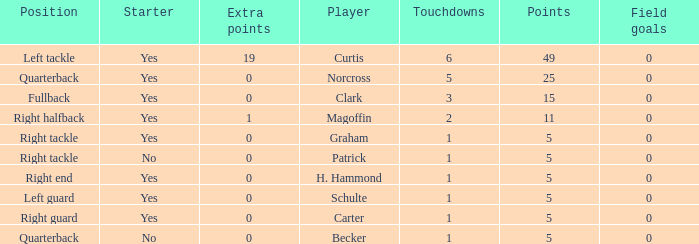Name the number of field goals for 19 extra points 1.0. 